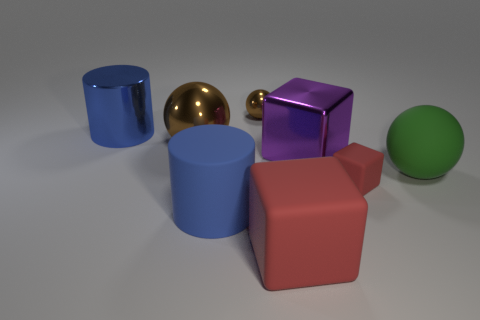Subtract all big red rubber blocks. How many blocks are left? 2 Add 1 large brown metallic things. How many objects exist? 9 Subtract all purple cubes. How many cubes are left? 2 Subtract all blocks. How many objects are left? 5 Subtract 1 red cubes. How many objects are left? 7 Subtract 2 balls. How many balls are left? 1 Subtract all yellow cubes. Subtract all cyan cylinders. How many cubes are left? 3 Subtract all cyan cubes. How many red spheres are left? 0 Subtract all big green matte spheres. Subtract all blue objects. How many objects are left? 5 Add 4 big red cubes. How many big red cubes are left? 5 